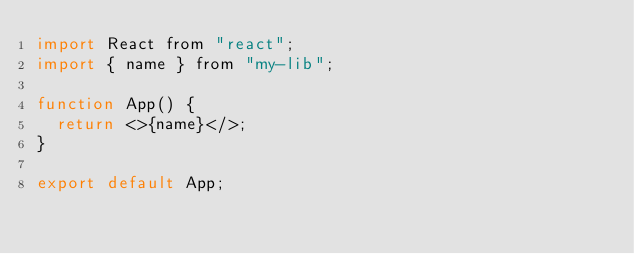<code> <loc_0><loc_0><loc_500><loc_500><_JavaScript_>import React from "react";
import { name } from "my-lib";

function App() {
  return <>{name}</>;
}

export default App;
</code> 